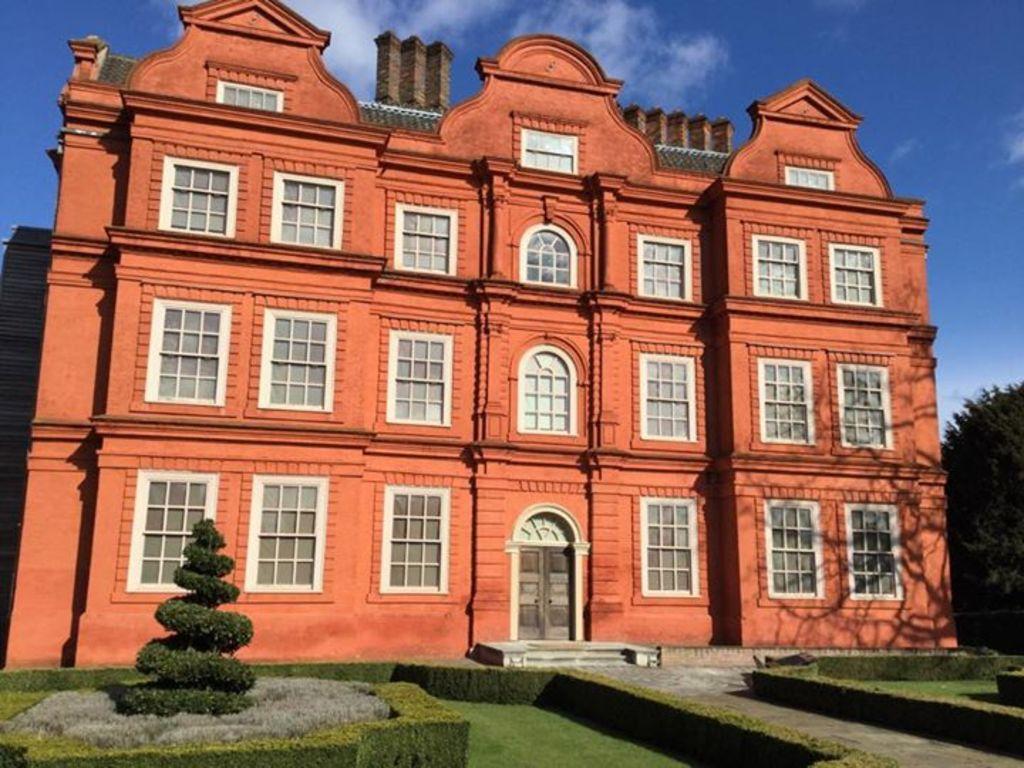Please provide a concise description of this image. In this image I can see a building, windows, door, trees and stairs. The sky is in blue and white color. 